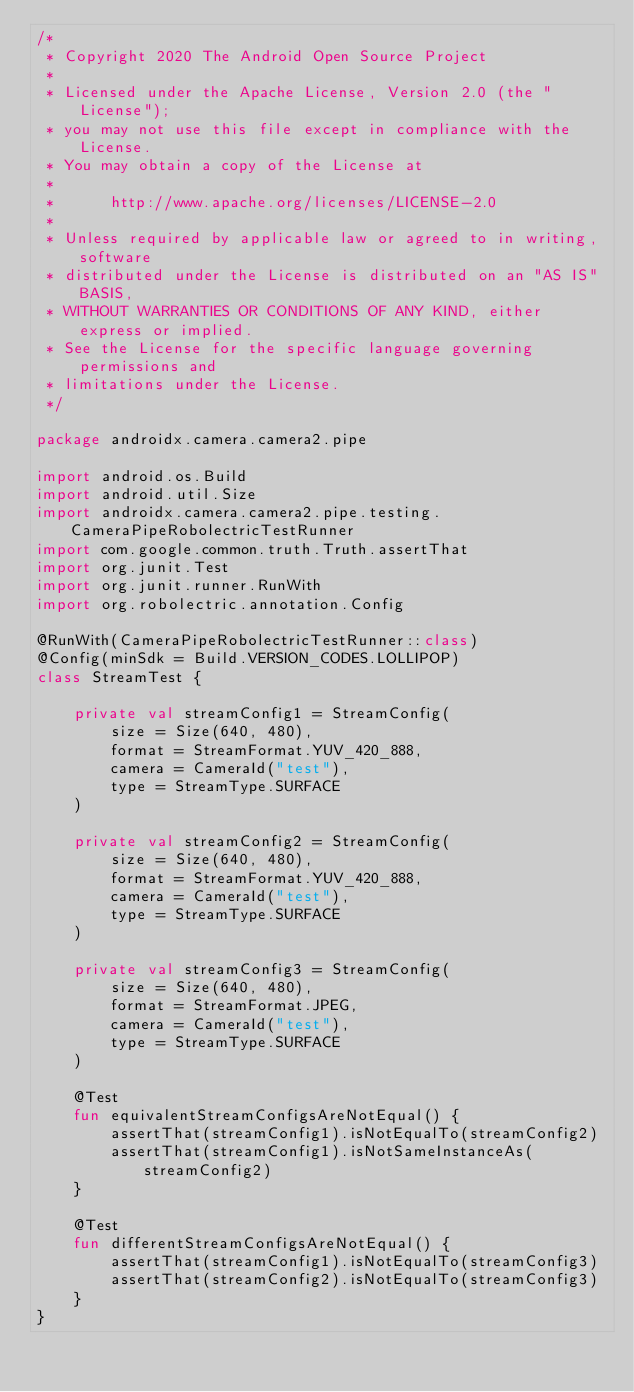Convert code to text. <code><loc_0><loc_0><loc_500><loc_500><_Kotlin_>/*
 * Copyright 2020 The Android Open Source Project
 *
 * Licensed under the Apache License, Version 2.0 (the "License");
 * you may not use this file except in compliance with the License.
 * You may obtain a copy of the License at
 *
 *      http://www.apache.org/licenses/LICENSE-2.0
 *
 * Unless required by applicable law or agreed to in writing, software
 * distributed under the License is distributed on an "AS IS" BASIS,
 * WITHOUT WARRANTIES OR CONDITIONS OF ANY KIND, either express or implied.
 * See the License for the specific language governing permissions and
 * limitations under the License.
 */

package androidx.camera.camera2.pipe

import android.os.Build
import android.util.Size
import androidx.camera.camera2.pipe.testing.CameraPipeRobolectricTestRunner
import com.google.common.truth.Truth.assertThat
import org.junit.Test
import org.junit.runner.RunWith
import org.robolectric.annotation.Config

@RunWith(CameraPipeRobolectricTestRunner::class)
@Config(minSdk = Build.VERSION_CODES.LOLLIPOP)
class StreamTest {

    private val streamConfig1 = StreamConfig(
        size = Size(640, 480),
        format = StreamFormat.YUV_420_888,
        camera = CameraId("test"),
        type = StreamType.SURFACE
    )

    private val streamConfig2 = StreamConfig(
        size = Size(640, 480),
        format = StreamFormat.YUV_420_888,
        camera = CameraId("test"),
        type = StreamType.SURFACE
    )

    private val streamConfig3 = StreamConfig(
        size = Size(640, 480),
        format = StreamFormat.JPEG,
        camera = CameraId("test"),
        type = StreamType.SURFACE
    )

    @Test
    fun equivalentStreamConfigsAreNotEqual() {
        assertThat(streamConfig1).isNotEqualTo(streamConfig2)
        assertThat(streamConfig1).isNotSameInstanceAs(streamConfig2)
    }

    @Test
    fun differentStreamConfigsAreNotEqual() {
        assertThat(streamConfig1).isNotEqualTo(streamConfig3)
        assertThat(streamConfig2).isNotEqualTo(streamConfig3)
    }
}
</code> 